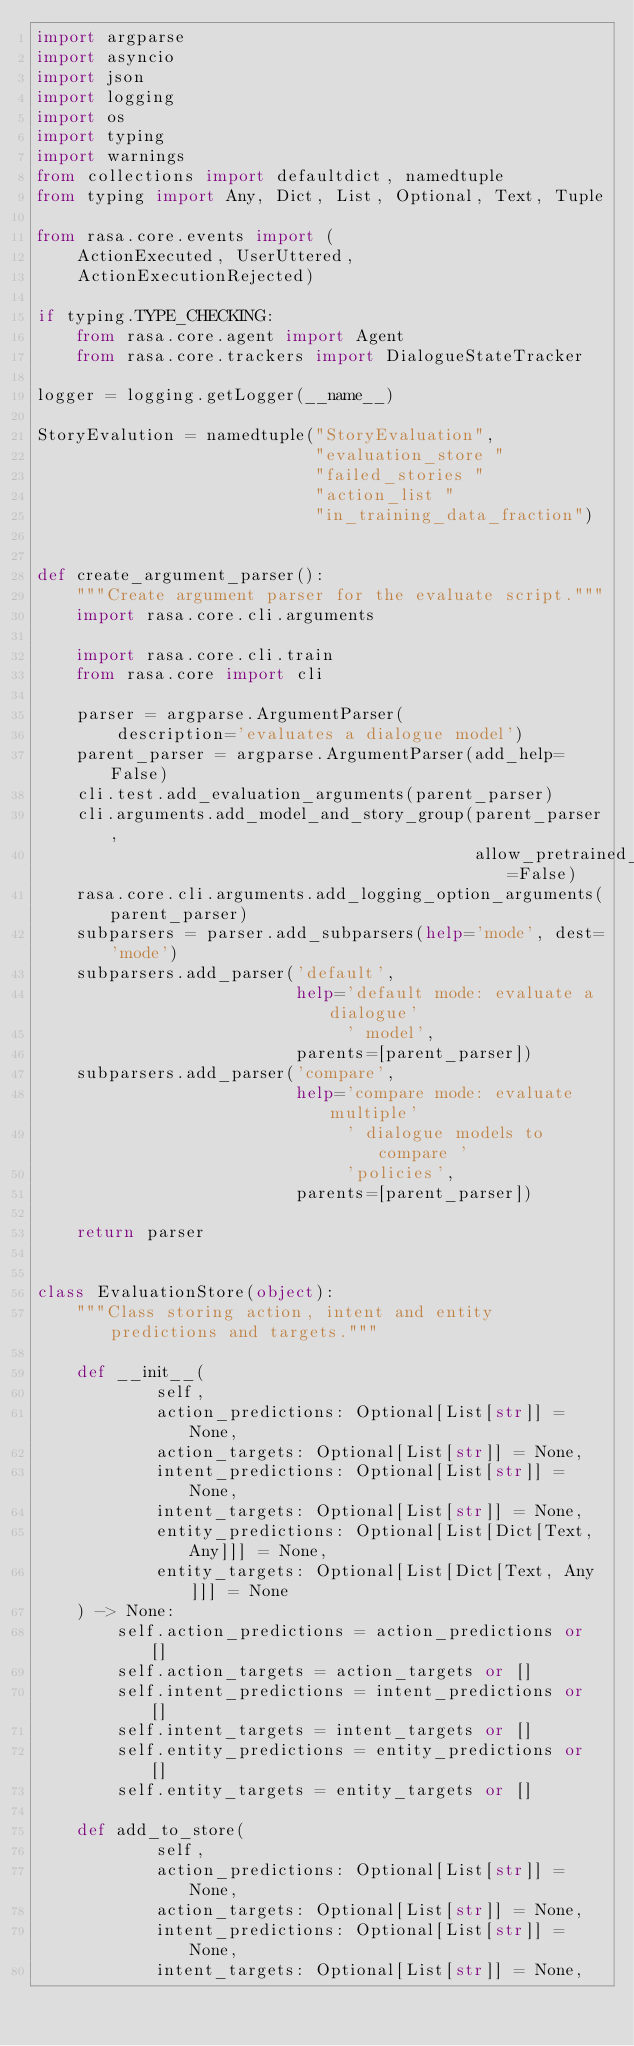<code> <loc_0><loc_0><loc_500><loc_500><_Python_>import argparse
import asyncio
import json
import logging
import os
import typing
import warnings
from collections import defaultdict, namedtuple
from typing import Any, Dict, List, Optional, Text, Tuple

from rasa.core.events import (
    ActionExecuted, UserUttered,
    ActionExecutionRejected)

if typing.TYPE_CHECKING:
    from rasa.core.agent import Agent
    from rasa.core.trackers import DialogueStateTracker

logger = logging.getLogger(__name__)

StoryEvalution = namedtuple("StoryEvaluation",
                            "evaluation_store "
                            "failed_stories "
                            "action_list "
                            "in_training_data_fraction")


def create_argument_parser():
    """Create argument parser for the evaluate script."""
    import rasa.core.cli.arguments

    import rasa.core.cli.train
    from rasa.core import cli

    parser = argparse.ArgumentParser(
        description='evaluates a dialogue model')
    parent_parser = argparse.ArgumentParser(add_help=False)
    cli.test.add_evaluation_arguments(parent_parser)
    cli.arguments.add_model_and_story_group(parent_parser,
                                            allow_pretrained_model=False)
    rasa.core.cli.arguments.add_logging_option_arguments(parent_parser)
    subparsers = parser.add_subparsers(help='mode', dest='mode')
    subparsers.add_parser('default',
                          help='default mode: evaluate a dialogue'
                               ' model',
                          parents=[parent_parser])
    subparsers.add_parser('compare',
                          help='compare mode: evaluate multiple'
                               ' dialogue models to compare '
                               'policies',
                          parents=[parent_parser])

    return parser


class EvaluationStore(object):
    """Class storing action, intent and entity predictions and targets."""

    def __init__(
            self,
            action_predictions: Optional[List[str]] = None,
            action_targets: Optional[List[str]] = None,
            intent_predictions: Optional[List[str]] = None,
            intent_targets: Optional[List[str]] = None,
            entity_predictions: Optional[List[Dict[Text, Any]]] = None,
            entity_targets: Optional[List[Dict[Text, Any]]] = None
    ) -> None:
        self.action_predictions = action_predictions or []
        self.action_targets = action_targets or []
        self.intent_predictions = intent_predictions or []
        self.intent_targets = intent_targets or []
        self.entity_predictions = entity_predictions or []
        self.entity_targets = entity_targets or []

    def add_to_store(
            self,
            action_predictions: Optional[List[str]] = None,
            action_targets: Optional[List[str]] = None,
            intent_predictions: Optional[List[str]] = None,
            intent_targets: Optional[List[str]] = None,</code> 